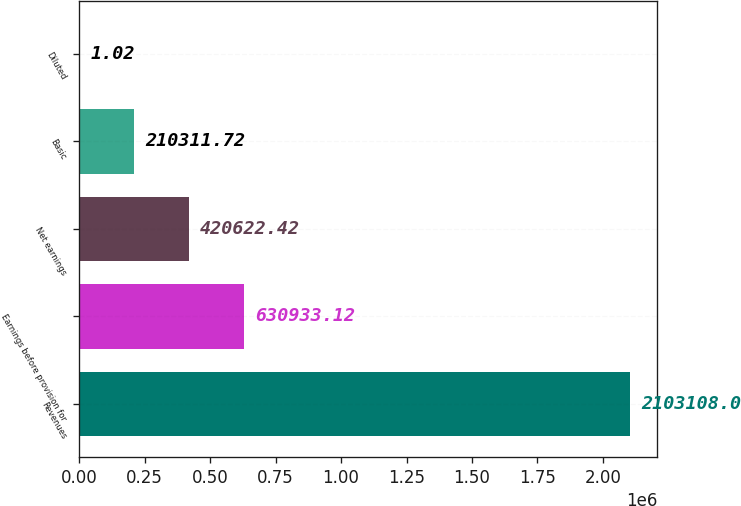Convert chart. <chart><loc_0><loc_0><loc_500><loc_500><bar_chart><fcel>Revenues<fcel>Earnings before provision for<fcel>Net earnings<fcel>Basic<fcel>Diluted<nl><fcel>2.10311e+06<fcel>630933<fcel>420622<fcel>210312<fcel>1.02<nl></chart> 